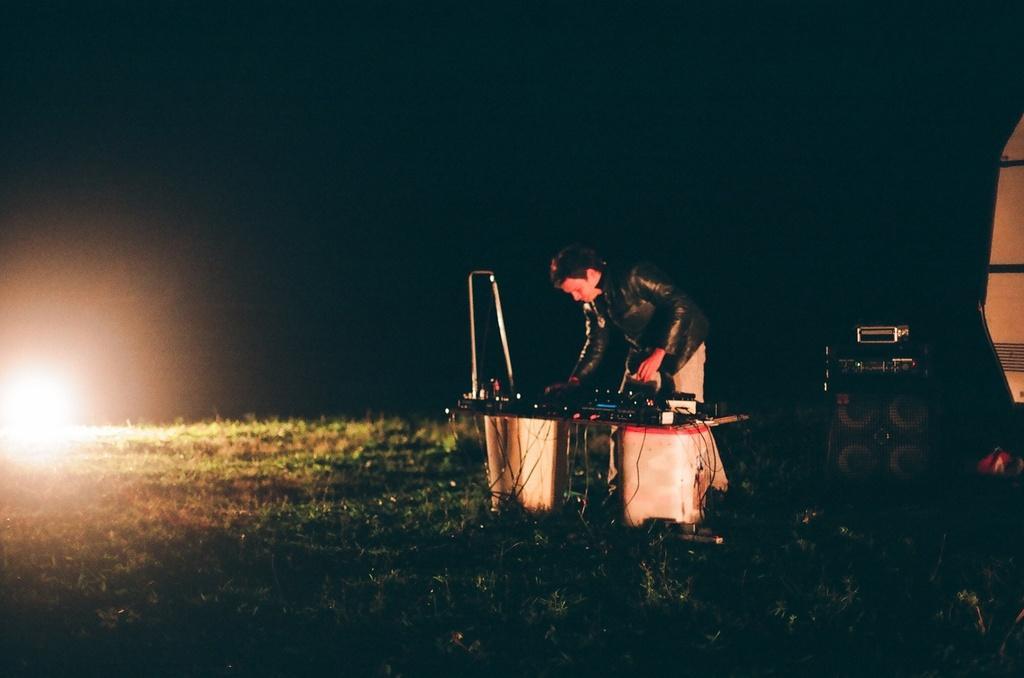How would you summarize this image in a sentence or two? In the picture I can see a man is standing on the ground. In the background I can see a vehicle, lights, the grass and some other objects on the ground. The background of the image is dark. 